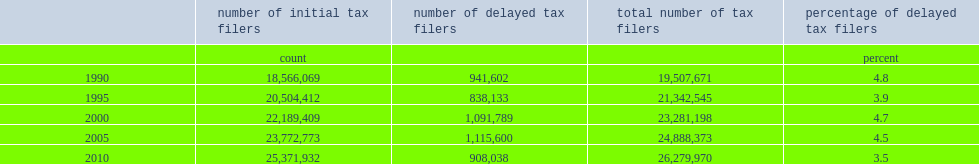In 2010,what was the proportion of tax filers who considered to be delayed tax filers? 3.5. In 1990,what was the proportion of tax filers who considered to be delayed tax filers? 4.8. Which year has the highest delayed tax filers rate? 1990.0. 